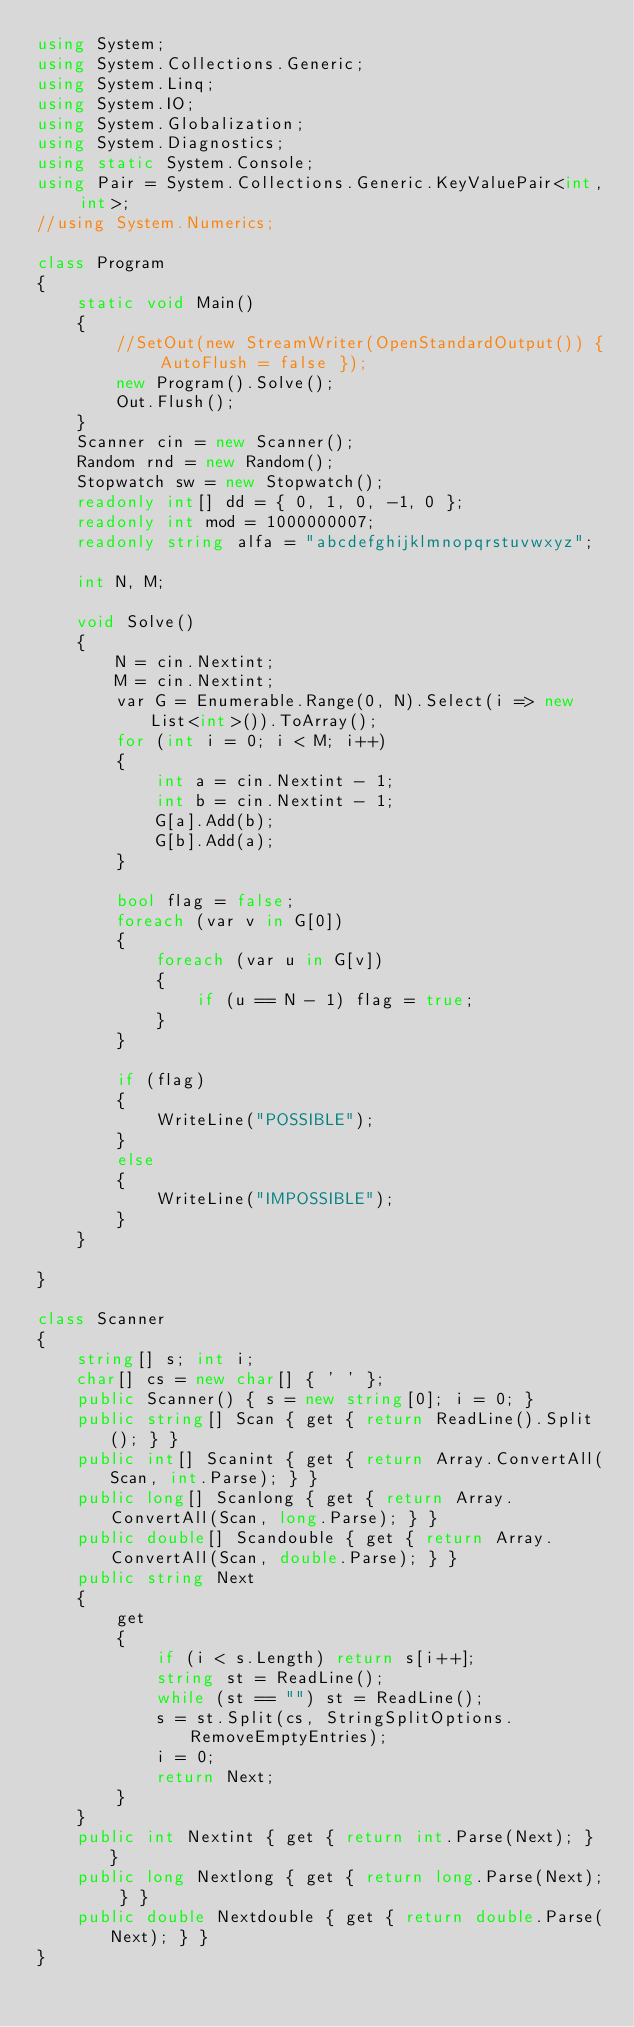<code> <loc_0><loc_0><loc_500><loc_500><_C#_>using System;
using System.Collections.Generic;
using System.Linq;
using System.IO;
using System.Globalization;
using System.Diagnostics;
using static System.Console;
using Pair = System.Collections.Generic.KeyValuePair<int, int>;
//using System.Numerics;

class Program
{
    static void Main()
    {
        //SetOut(new StreamWriter(OpenStandardOutput()) { AutoFlush = false });
        new Program().Solve();
        Out.Flush();
    }
    Scanner cin = new Scanner();
    Random rnd = new Random();
    Stopwatch sw = new Stopwatch();
    readonly int[] dd = { 0, 1, 0, -1, 0 };
    readonly int mod = 1000000007;
    readonly string alfa = "abcdefghijklmnopqrstuvwxyz";

    int N, M;
    
    void Solve()
    {
        N = cin.Nextint;
        M = cin.Nextint;
        var G = Enumerable.Range(0, N).Select(i => new List<int>()).ToArray();
        for (int i = 0; i < M; i++)
        {
            int a = cin.Nextint - 1;
            int b = cin.Nextint - 1;
            G[a].Add(b);
            G[b].Add(a);
        }

        bool flag = false;
        foreach (var v in G[0])
        {
            foreach (var u in G[v])
            {
                if (u == N - 1) flag = true;
            }
        }

        if (flag)
        {
            WriteLine("POSSIBLE");
        }
        else
        {
            WriteLine("IMPOSSIBLE");
        }
    }

}

class Scanner
{
    string[] s; int i;
    char[] cs = new char[] { ' ' };
    public Scanner() { s = new string[0]; i = 0; }
    public string[] Scan { get { return ReadLine().Split(); } }
    public int[] Scanint { get { return Array.ConvertAll(Scan, int.Parse); } }
    public long[] Scanlong { get { return Array.ConvertAll(Scan, long.Parse); } }
    public double[] Scandouble { get { return Array.ConvertAll(Scan, double.Parse); } }
    public string Next
    {
        get
        {
            if (i < s.Length) return s[i++];
            string st = ReadLine();
            while (st == "") st = ReadLine();
            s = st.Split(cs, StringSplitOptions.RemoveEmptyEntries);
            i = 0;
            return Next;
        }
    }
    public int Nextint { get { return int.Parse(Next); } }
    public long Nextlong { get { return long.Parse(Next); } }
    public double Nextdouble { get { return double.Parse(Next); } }
}</code> 